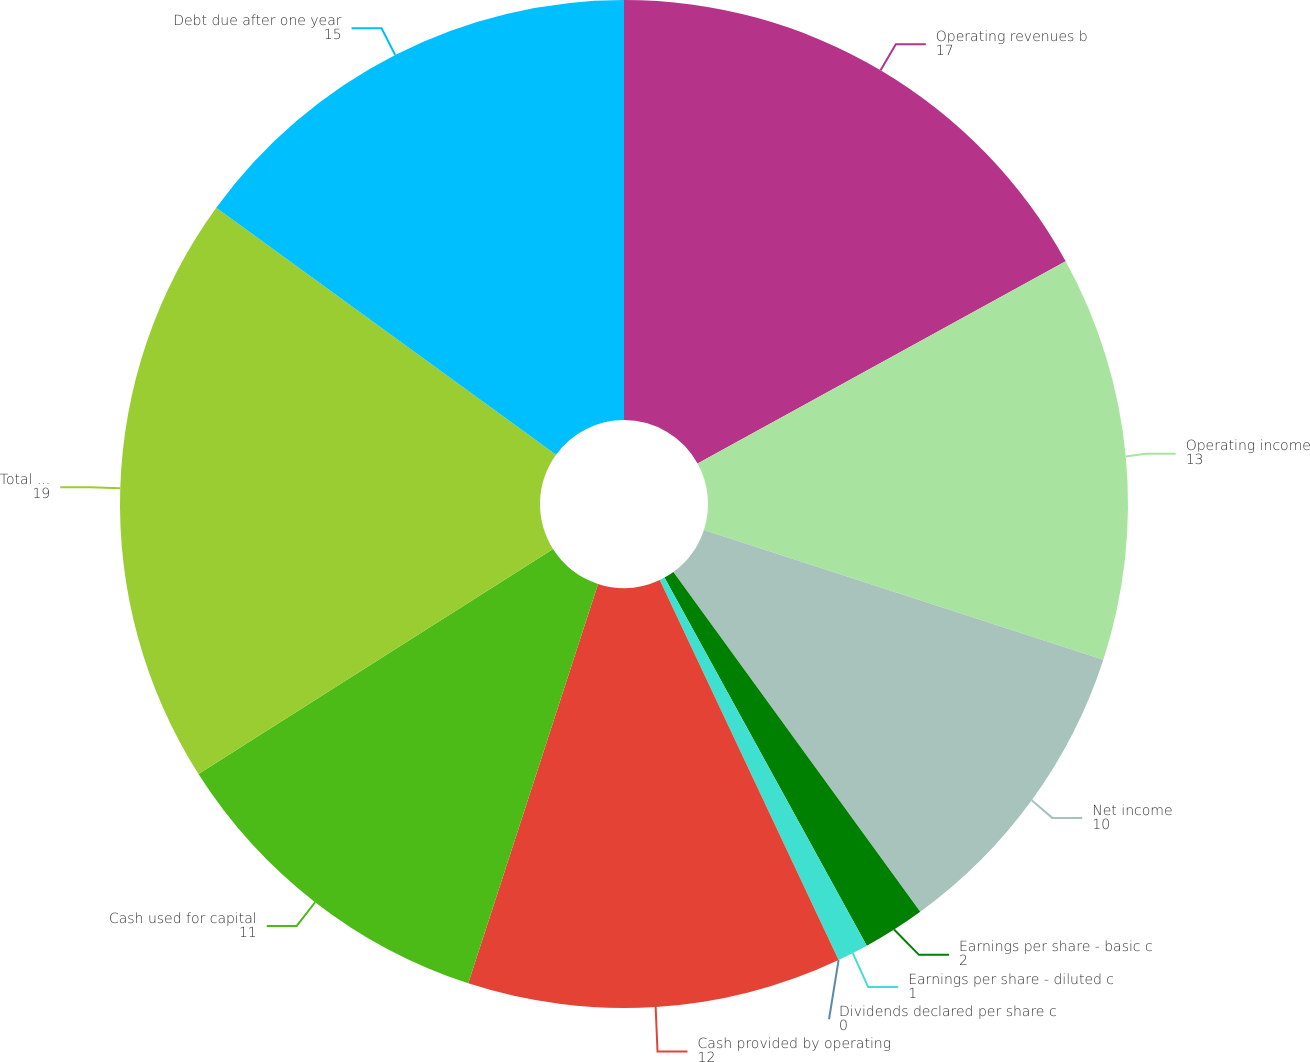Convert chart. <chart><loc_0><loc_0><loc_500><loc_500><pie_chart><fcel>Operating revenues b<fcel>Operating income<fcel>Net income<fcel>Earnings per share - basic c<fcel>Earnings per share - diluted c<fcel>Dividends declared per share c<fcel>Cash provided by operating<fcel>Cash used for capital<fcel>Total assets<fcel>Debt due after one year<nl><fcel>17.0%<fcel>13.0%<fcel>10.0%<fcel>2.0%<fcel>1.0%<fcel>0.0%<fcel>12.0%<fcel>11.0%<fcel>19.0%<fcel>15.0%<nl></chart> 